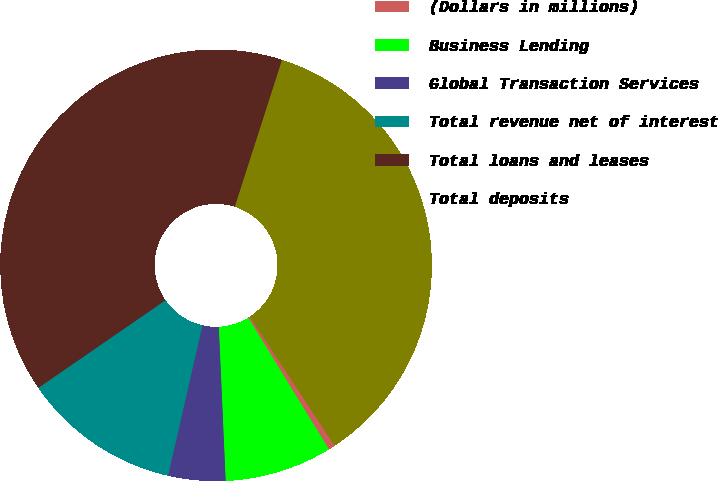Convert chart to OTSL. <chart><loc_0><loc_0><loc_500><loc_500><pie_chart><fcel>(Dollars in millions)<fcel>Business Lending<fcel>Global Transaction Services<fcel>Total revenue net of interest<fcel>Total loans and leases<fcel>Total deposits<nl><fcel>0.5%<fcel>8.05%<fcel>4.28%<fcel>11.82%<fcel>39.56%<fcel>35.79%<nl></chart> 